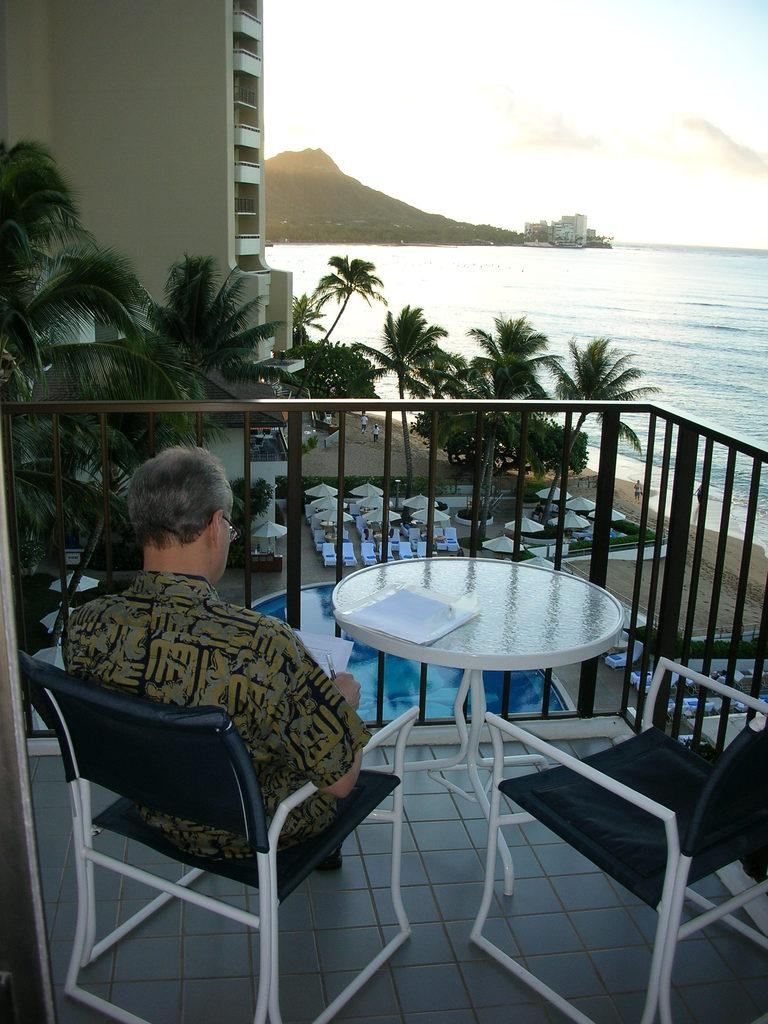What can be seen in the sky in the image? There is water in the image. What type of environment is depicted in the image? The image features plants, water, and a sky, suggesting a natural setting. What is the man in the image doing? The man is sitting on a chair in the image. What is the man wearing? The man is wearing a brown color shirt. What object is in front of the man? There is a book in front of the man. What type of knife is the man using to cut the blade in the image? There is no knife or blade present in the image. What type of apparel is the man wearing on his feet in the image? The provided facts do not mention the man's footwear, so it cannot be determined from the image. 